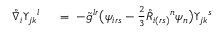Convert formula to latex. <formula><loc_0><loc_0><loc_500><loc_500>\begin{array} { r l } { \mathring { \nabla } _ { i } \Upsilon _ { j k ^ { l } \ } & = \ - \tilde { g } ^ { l r } \left ( \psi _ { i r s } - \frac { 2 } { 3 } \mathring { R } _ { i ( r s ) ^ { n } \psi _ { n } \right ) \Upsilon _ { j k ^ { s } } \end{array}</formula> 